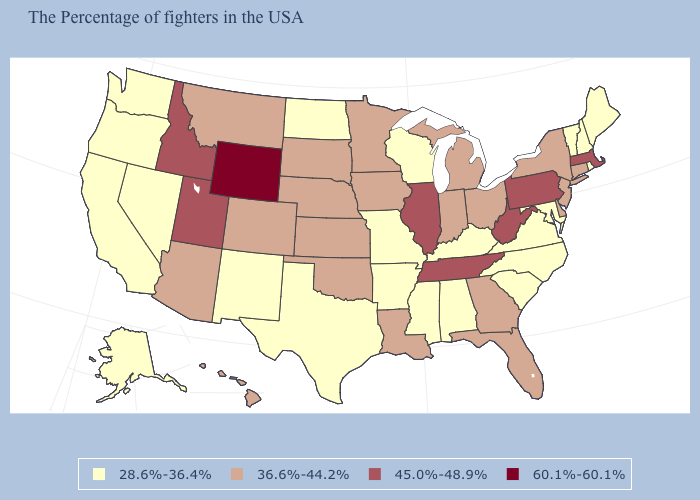Among the states that border Connecticut , does Massachusetts have the highest value?
Be succinct. Yes. Is the legend a continuous bar?
Give a very brief answer. No. What is the value of Montana?
Keep it brief. 36.6%-44.2%. Does Hawaii have the lowest value in the West?
Concise answer only. No. What is the lowest value in states that border North Carolina?
Answer briefly. 28.6%-36.4%. What is the value of Arizona?
Keep it brief. 36.6%-44.2%. What is the value of Nebraska?
Keep it brief. 36.6%-44.2%. Does the first symbol in the legend represent the smallest category?
Write a very short answer. Yes. Name the states that have a value in the range 45.0%-48.9%?
Quick response, please. Massachusetts, Pennsylvania, West Virginia, Tennessee, Illinois, Utah, Idaho. Name the states that have a value in the range 36.6%-44.2%?
Quick response, please. Connecticut, New York, New Jersey, Delaware, Ohio, Florida, Georgia, Michigan, Indiana, Louisiana, Minnesota, Iowa, Kansas, Nebraska, Oklahoma, South Dakota, Colorado, Montana, Arizona, Hawaii. What is the highest value in the USA?
Answer briefly. 60.1%-60.1%. Which states hav the highest value in the South?
Write a very short answer. West Virginia, Tennessee. What is the value of Hawaii?
Give a very brief answer. 36.6%-44.2%. What is the value of Michigan?
Quick response, please. 36.6%-44.2%. Does Wyoming have the highest value in the USA?
Keep it brief. Yes. 